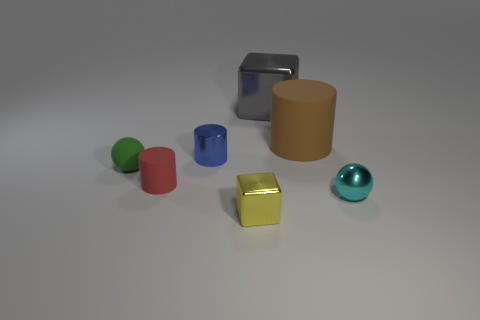Is there a tiny cyan thing that is on the left side of the blue cylinder behind the cyan thing?
Provide a succinct answer. No. There is a brown object that is the same shape as the small blue object; what is it made of?
Keep it short and to the point. Rubber. Are there more spheres to the right of the green object than small green rubber spheres on the right side of the gray cube?
Ensure brevity in your answer.  Yes. There is a big thing that is the same material as the small yellow object; what is its shape?
Offer a very short reply. Cube. Are there more small metal things that are in front of the tiny metallic sphere than rubber objects?
Give a very brief answer. No. How many tiny matte cylinders have the same color as the metallic cylinder?
Your answer should be very brief. 0. How many other things are the same color as the big block?
Your response must be concise. 0. Are there more tiny green objects than brown metallic spheres?
Ensure brevity in your answer.  Yes. What is the material of the small green object?
Provide a short and direct response. Rubber. There is a cylinder that is in front of the green rubber sphere; does it have the same size as the gray block?
Offer a very short reply. No. 